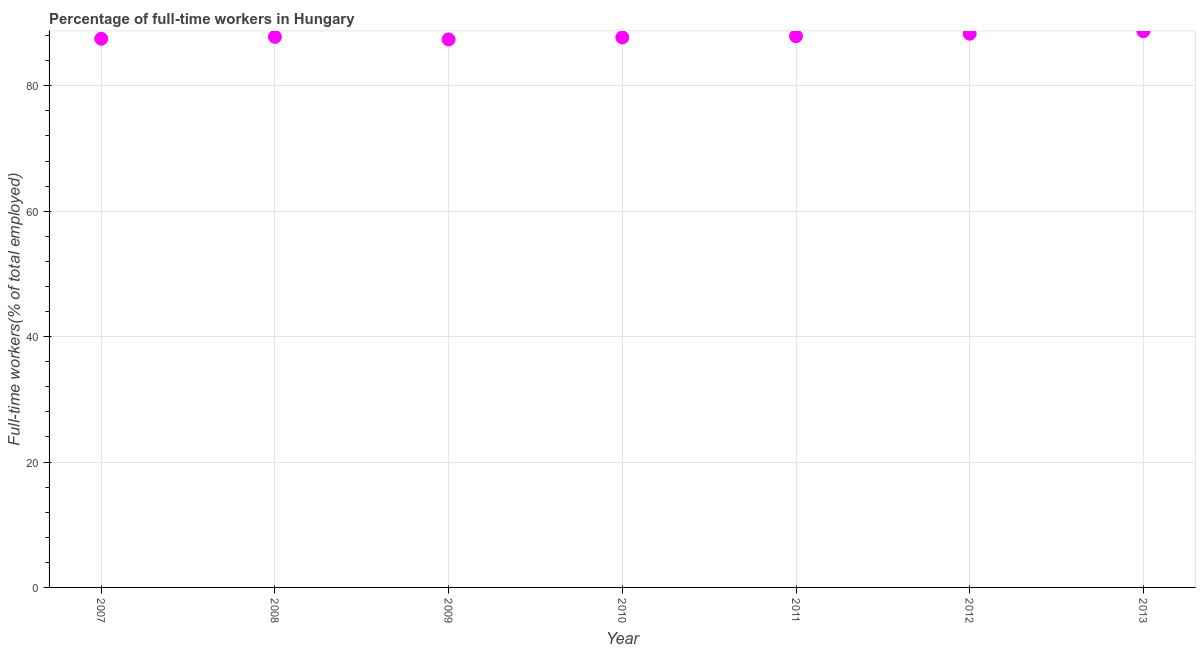What is the percentage of full-time workers in 2007?
Your response must be concise. 87.5. Across all years, what is the maximum percentage of full-time workers?
Provide a succinct answer. 88.7. Across all years, what is the minimum percentage of full-time workers?
Provide a succinct answer. 87.4. In which year was the percentage of full-time workers maximum?
Give a very brief answer. 2013. In which year was the percentage of full-time workers minimum?
Offer a very short reply. 2009. What is the sum of the percentage of full-time workers?
Keep it short and to the point. 615.3. What is the difference between the percentage of full-time workers in 2009 and 2012?
Your answer should be very brief. -0.9. What is the average percentage of full-time workers per year?
Ensure brevity in your answer.  87.9. What is the median percentage of full-time workers?
Offer a terse response. 87.8. In how many years, is the percentage of full-time workers greater than 24 %?
Provide a succinct answer. 7. What is the ratio of the percentage of full-time workers in 2008 to that in 2013?
Keep it short and to the point. 0.99. Is the difference between the percentage of full-time workers in 2010 and 2011 greater than the difference between any two years?
Keep it short and to the point. No. What is the difference between the highest and the second highest percentage of full-time workers?
Your answer should be compact. 0.4. Is the sum of the percentage of full-time workers in 2009 and 2011 greater than the maximum percentage of full-time workers across all years?
Make the answer very short. Yes. What is the difference between the highest and the lowest percentage of full-time workers?
Keep it short and to the point. 1.3. In how many years, is the percentage of full-time workers greater than the average percentage of full-time workers taken over all years?
Give a very brief answer. 3. How many dotlines are there?
Give a very brief answer. 1. How many years are there in the graph?
Ensure brevity in your answer.  7. What is the difference between two consecutive major ticks on the Y-axis?
Make the answer very short. 20. Are the values on the major ticks of Y-axis written in scientific E-notation?
Make the answer very short. No. Does the graph contain any zero values?
Your answer should be compact. No. What is the title of the graph?
Offer a very short reply. Percentage of full-time workers in Hungary. What is the label or title of the X-axis?
Your answer should be very brief. Year. What is the label or title of the Y-axis?
Your answer should be compact. Full-time workers(% of total employed). What is the Full-time workers(% of total employed) in 2007?
Your answer should be compact. 87.5. What is the Full-time workers(% of total employed) in 2008?
Your answer should be compact. 87.8. What is the Full-time workers(% of total employed) in 2009?
Keep it short and to the point. 87.4. What is the Full-time workers(% of total employed) in 2010?
Offer a terse response. 87.7. What is the Full-time workers(% of total employed) in 2011?
Your answer should be very brief. 87.9. What is the Full-time workers(% of total employed) in 2012?
Offer a very short reply. 88.3. What is the Full-time workers(% of total employed) in 2013?
Make the answer very short. 88.7. What is the difference between the Full-time workers(% of total employed) in 2007 and 2008?
Give a very brief answer. -0.3. What is the difference between the Full-time workers(% of total employed) in 2007 and 2009?
Your answer should be compact. 0.1. What is the difference between the Full-time workers(% of total employed) in 2007 and 2010?
Offer a terse response. -0.2. What is the difference between the Full-time workers(% of total employed) in 2007 and 2011?
Provide a short and direct response. -0.4. What is the difference between the Full-time workers(% of total employed) in 2007 and 2012?
Your response must be concise. -0.8. What is the difference between the Full-time workers(% of total employed) in 2007 and 2013?
Make the answer very short. -1.2. What is the difference between the Full-time workers(% of total employed) in 2008 and 2010?
Your answer should be very brief. 0.1. What is the difference between the Full-time workers(% of total employed) in 2008 and 2013?
Keep it short and to the point. -0.9. What is the difference between the Full-time workers(% of total employed) in 2009 and 2011?
Your answer should be compact. -0.5. What is the difference between the Full-time workers(% of total employed) in 2009 and 2012?
Offer a terse response. -0.9. What is the difference between the Full-time workers(% of total employed) in 2009 and 2013?
Your answer should be compact. -1.3. What is the difference between the Full-time workers(% of total employed) in 2010 and 2011?
Your answer should be very brief. -0.2. What is the difference between the Full-time workers(% of total employed) in 2010 and 2012?
Offer a very short reply. -0.6. What is the difference between the Full-time workers(% of total employed) in 2010 and 2013?
Your answer should be very brief. -1. What is the difference between the Full-time workers(% of total employed) in 2011 and 2013?
Ensure brevity in your answer.  -0.8. What is the difference between the Full-time workers(% of total employed) in 2012 and 2013?
Your answer should be very brief. -0.4. What is the ratio of the Full-time workers(% of total employed) in 2007 to that in 2009?
Your answer should be very brief. 1. What is the ratio of the Full-time workers(% of total employed) in 2007 to that in 2010?
Your answer should be very brief. 1. What is the ratio of the Full-time workers(% of total employed) in 2007 to that in 2012?
Offer a terse response. 0.99. What is the ratio of the Full-time workers(% of total employed) in 2008 to that in 2009?
Make the answer very short. 1. What is the ratio of the Full-time workers(% of total employed) in 2008 to that in 2011?
Make the answer very short. 1. What is the ratio of the Full-time workers(% of total employed) in 2008 to that in 2012?
Your answer should be very brief. 0.99. What is the ratio of the Full-time workers(% of total employed) in 2009 to that in 2010?
Keep it short and to the point. 1. What is the ratio of the Full-time workers(% of total employed) in 2010 to that in 2012?
Give a very brief answer. 0.99. What is the ratio of the Full-time workers(% of total employed) in 2011 to that in 2012?
Your answer should be compact. 0.99. What is the ratio of the Full-time workers(% of total employed) in 2011 to that in 2013?
Provide a succinct answer. 0.99. 